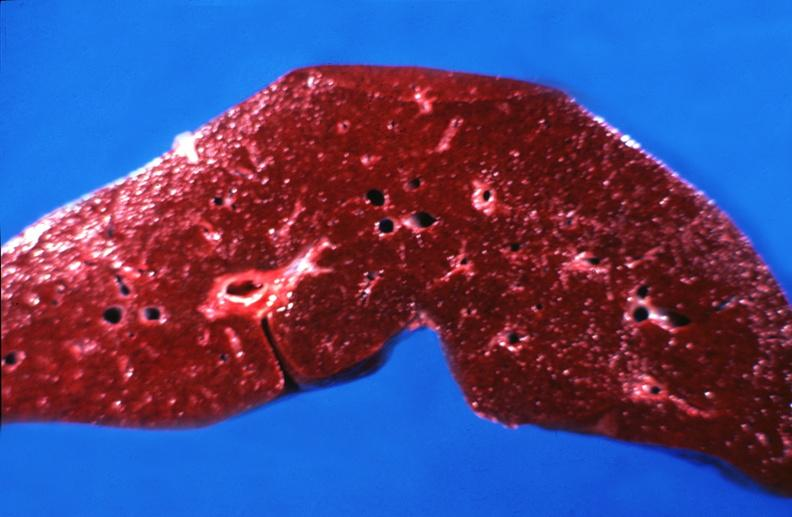what is present?
Answer the question using a single word or phrase. Hepatobiliary 